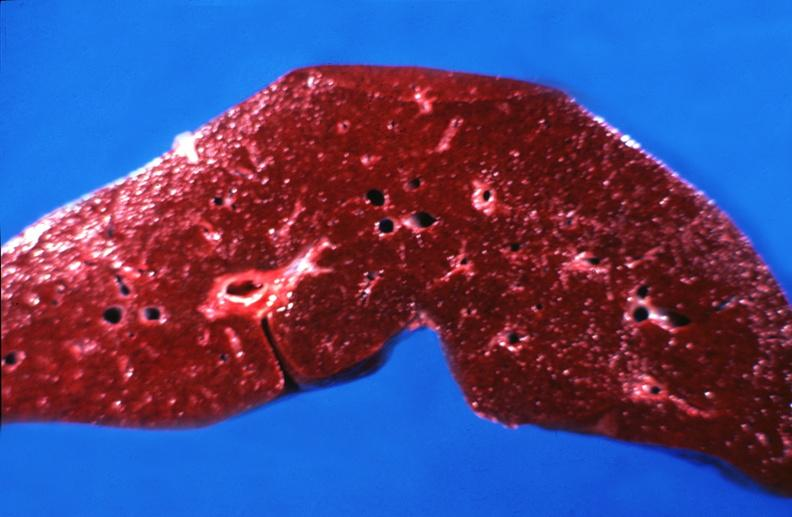what is present?
Answer the question using a single word or phrase. Hepatobiliary 